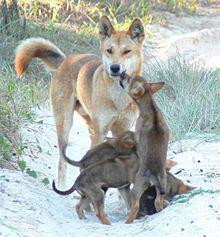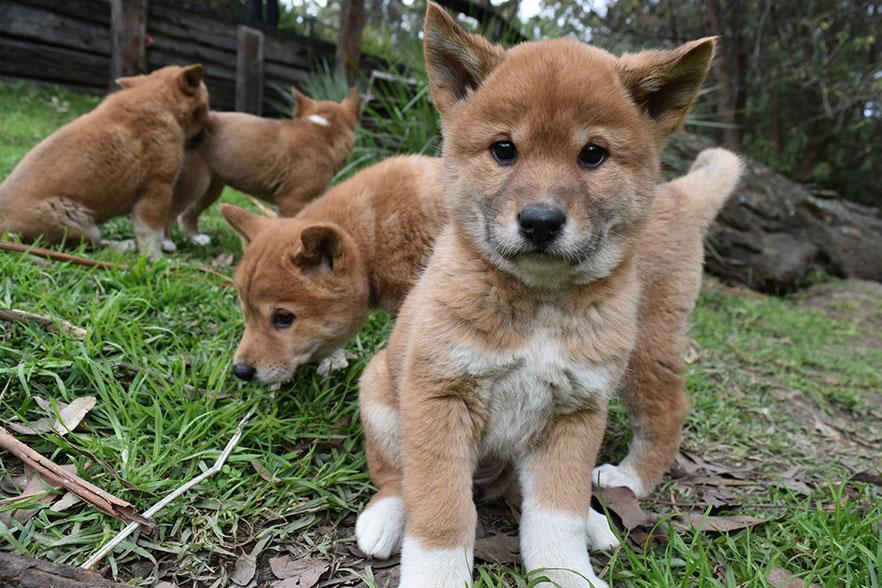The first image is the image on the left, the second image is the image on the right. For the images displayed, is the sentence "Each image contains exactly one dingo, and no dog looks levelly at the camera." factually correct? Answer yes or no. No. The first image is the image on the left, the second image is the image on the right. Examine the images to the left and right. Is the description "There are two dogs in the pair of images." accurate? Answer yes or no. No. 